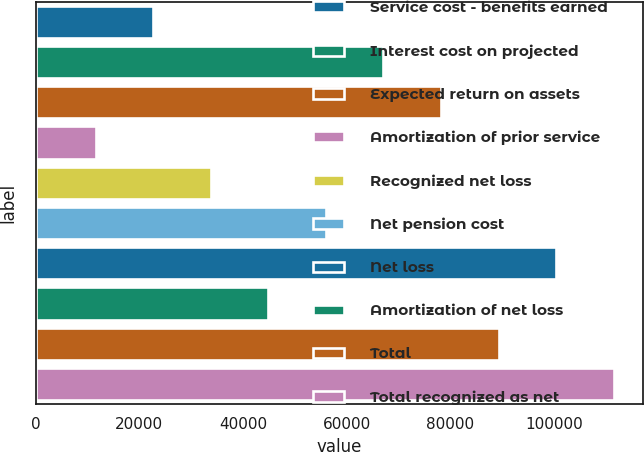Convert chart. <chart><loc_0><loc_0><loc_500><loc_500><bar_chart><fcel>Service cost - benefits earned<fcel>Interest cost on projected<fcel>Expected return on assets<fcel>Amortization of prior service<fcel>Recognized net loss<fcel>Net pension cost<fcel>Net loss<fcel>Amortization of net loss<fcel>Total<fcel>Total recognized as net<nl><fcel>22674<fcel>67104<fcel>78211.5<fcel>11566.5<fcel>33781.5<fcel>55996.5<fcel>100426<fcel>44889<fcel>89319<fcel>111534<nl></chart> 